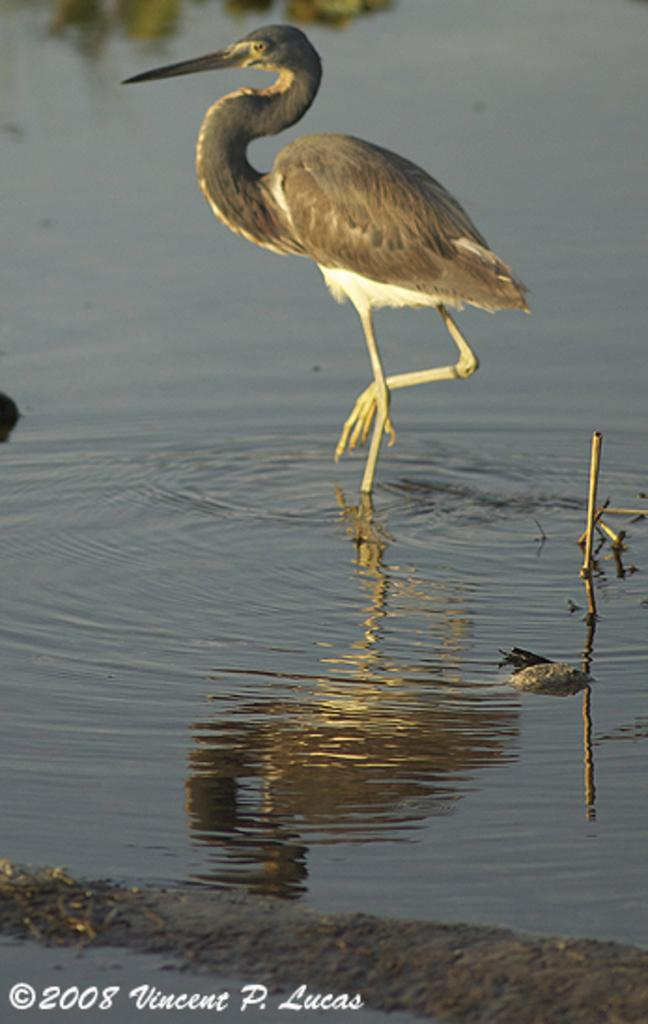What is the main subject of the image? There is a crane in the image. What is the crane doing in the image? The crane is walking in the water. What type of environment is depicted in the image? There is water visible at the bottom of the image. What type of cushion can be seen in the image? There is no cushion present in the image. 